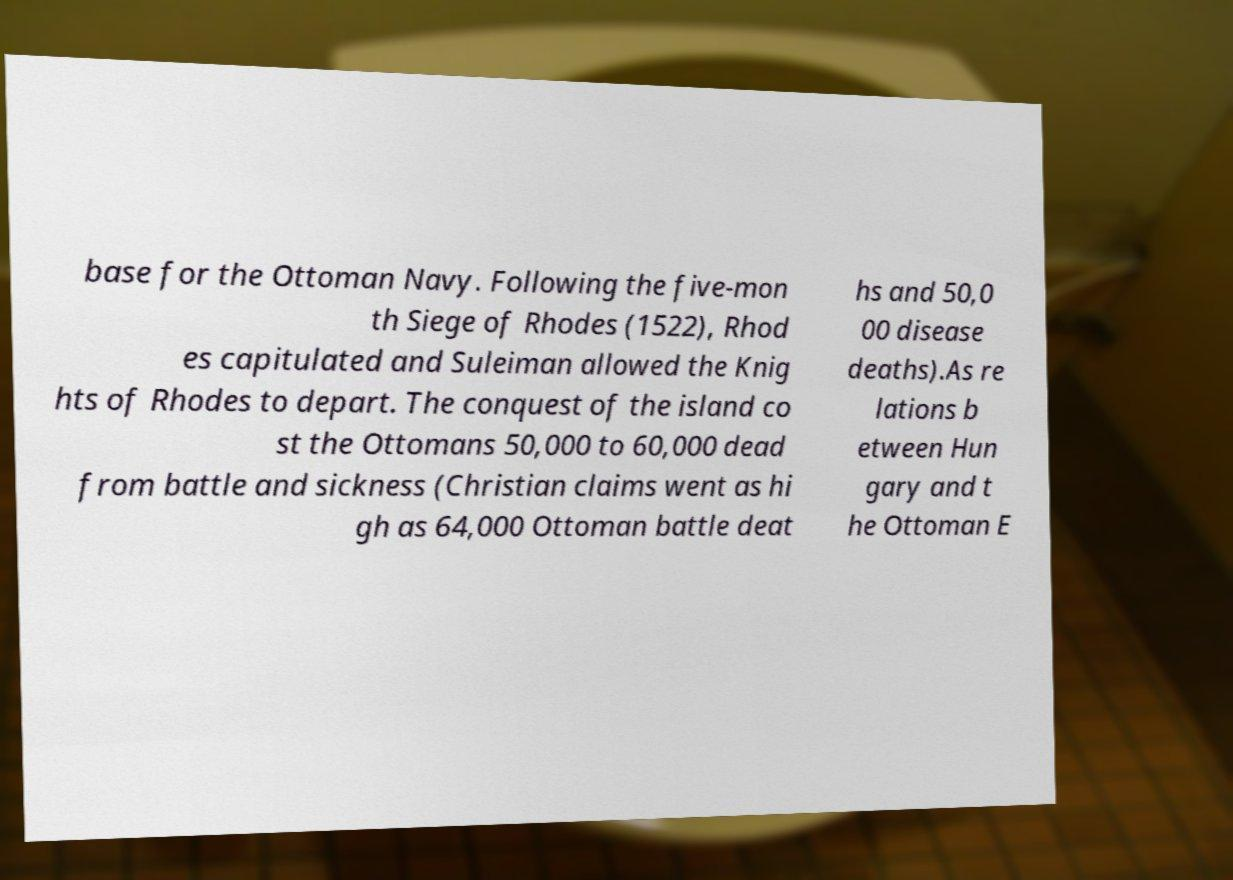Could you extract and type out the text from this image? base for the Ottoman Navy. Following the five-mon th Siege of Rhodes (1522), Rhod es capitulated and Suleiman allowed the Knig hts of Rhodes to depart. The conquest of the island co st the Ottomans 50,000 to 60,000 dead from battle and sickness (Christian claims went as hi gh as 64,000 Ottoman battle deat hs and 50,0 00 disease deaths).As re lations b etween Hun gary and t he Ottoman E 